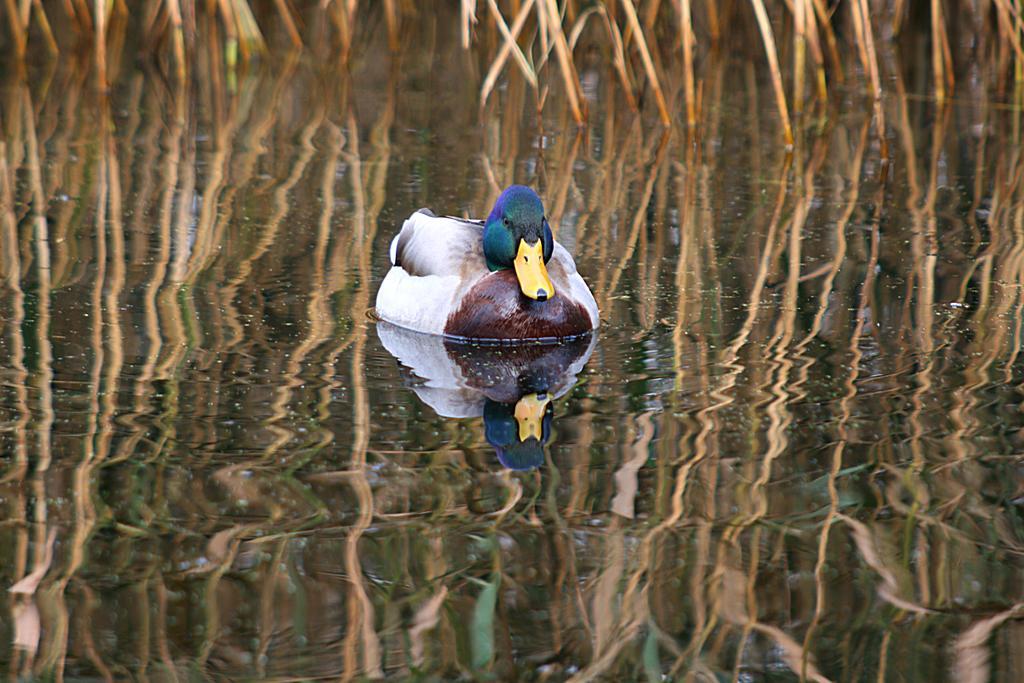Could you give a brief overview of what you see in this image? In this picture there is a duck on the water. At the bottom i can see the duck and plants in the reflection. 